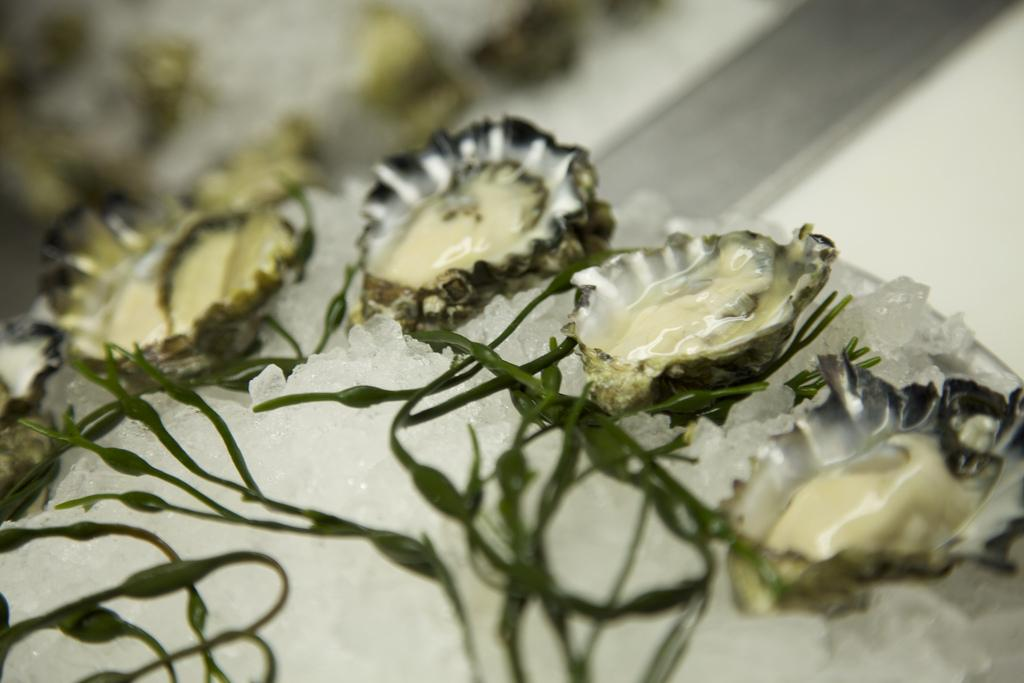What type of seafood is present in the image? There are oysters in the image. How are the oysters being stored or displayed? The oysters are kept on ice. What type of cable is being used to connect the oysters to the hospital in the image? There is no cable or hospital present in the image; it only features oysters kept on ice. 